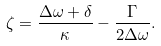<formula> <loc_0><loc_0><loc_500><loc_500>\zeta = \frac { \Delta \omega + \delta } { \kappa } - \frac { \Gamma } { 2 \Delta \omega } .</formula> 